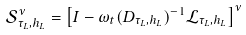Convert formula to latex. <formula><loc_0><loc_0><loc_500><loc_500>\mathcal { S } _ { \tau _ { L } , h _ { L } } ^ { \nu } = \left [ I - \omega _ { t } ( D _ { \tau _ { L } , h _ { L } } ) ^ { - 1 } \mathcal { L } _ { \tau _ { L } , h _ { L } } \right ] ^ { \nu }</formula> 